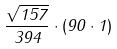<formula> <loc_0><loc_0><loc_500><loc_500>\frac { \sqrt { 1 5 7 } } { 3 9 4 } \cdot ( 9 0 \cdot 1 )</formula> 